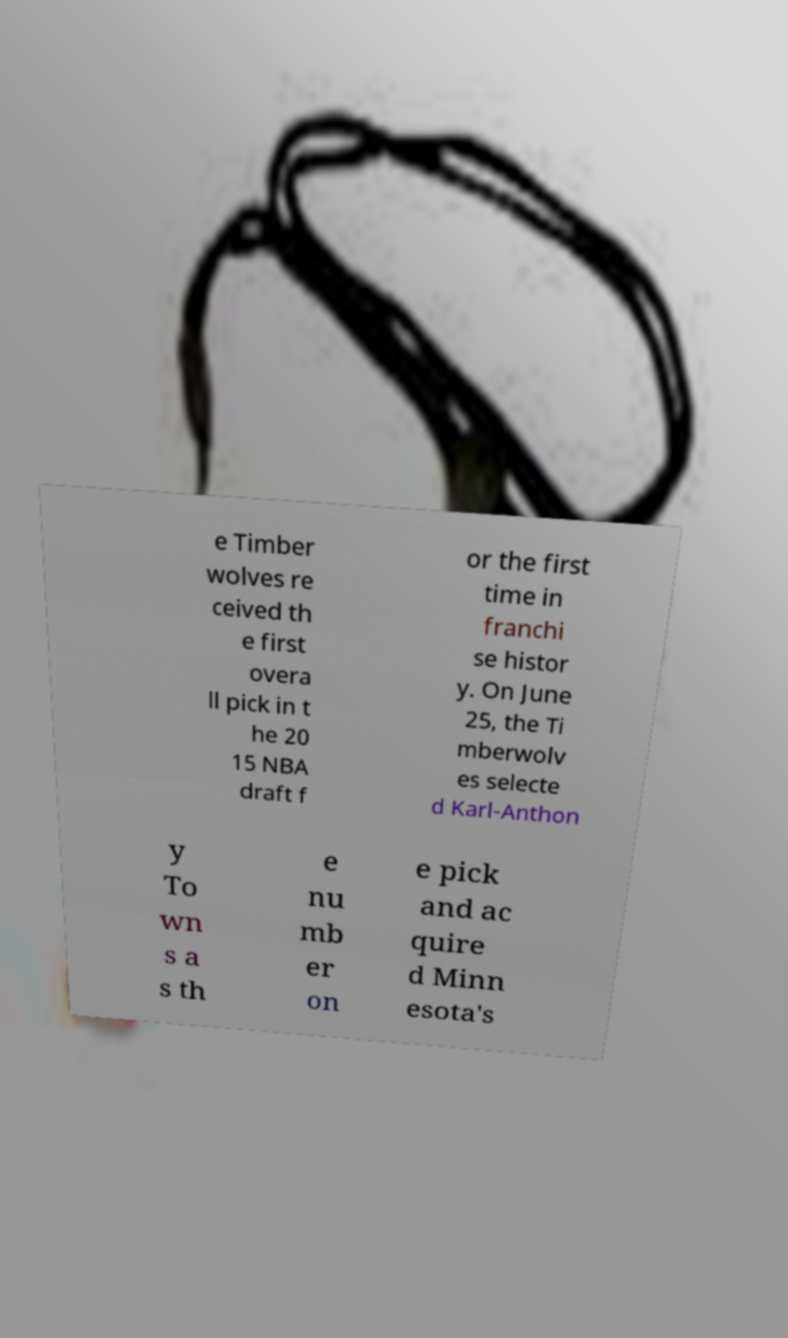Please read and relay the text visible in this image. What does it say? e Timber wolves re ceived th e first overa ll pick in t he 20 15 NBA draft f or the first time in franchi se histor y. On June 25, the Ti mberwolv es selecte d Karl-Anthon y To wn s a s th e nu mb er on e pick and ac quire d Minn esota's 